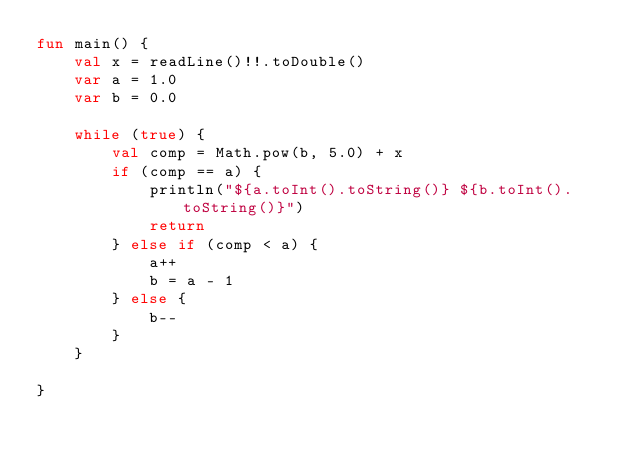<code> <loc_0><loc_0><loc_500><loc_500><_Kotlin_>fun main() {
    val x = readLine()!!.toDouble()
    var a = 1.0
    var b = 0.0

    while (true) {
        val comp = Math.pow(b, 5.0) + x
        if (comp == a) {
            println("${a.toInt().toString()} ${b.toInt().toString()}")
            return
        } else if (comp < a) {
            a++
            b = a - 1
        } else {
            b--
        }
    }

}

</code> 